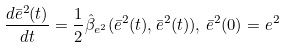Convert formula to latex. <formula><loc_0><loc_0><loc_500><loc_500>\frac { d \bar { e } ^ { 2 } ( t ) } { d t } = \frac { 1 } { 2 } \hat { \beta } _ { e ^ { 2 } } ( \bar { e } ^ { 2 } ( t ) , \bar { e } ^ { 2 } ( t ) ) , \, \bar { e } ^ { 2 } ( 0 ) = e ^ { 2 }</formula> 